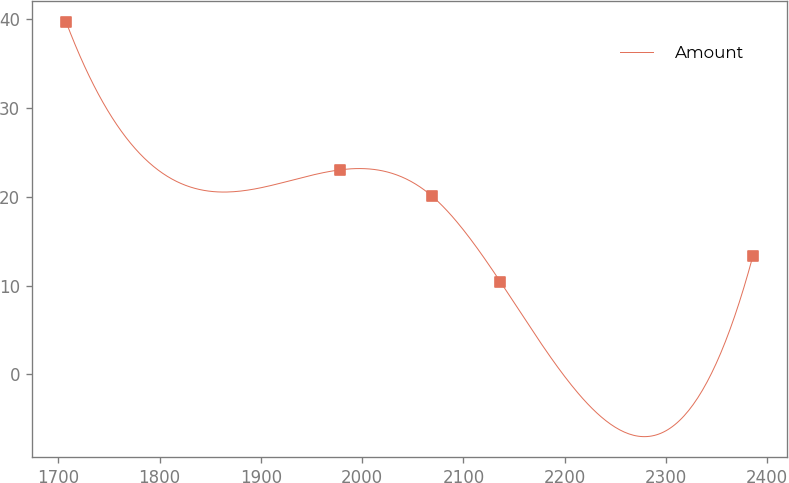Convert chart. <chart><loc_0><loc_0><loc_500><loc_500><line_chart><ecel><fcel>Amount<nl><fcel>1707.63<fcel>39.68<nl><fcel>1977.86<fcel>23.04<nl><fcel>2068.61<fcel>20.12<nl><fcel>2136.44<fcel>10.44<nl><fcel>2385.89<fcel>13.36<nl></chart> 